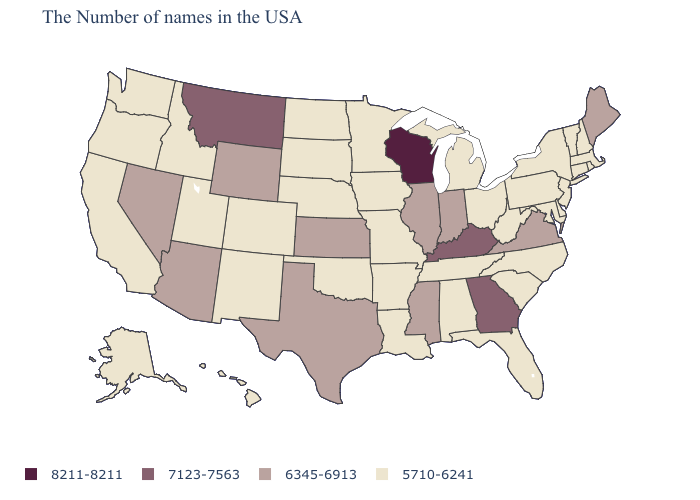Name the states that have a value in the range 6345-6913?
Be succinct. Maine, Virginia, Indiana, Illinois, Mississippi, Kansas, Texas, Wyoming, Arizona, Nevada. What is the value of Iowa?
Keep it brief. 5710-6241. What is the lowest value in states that border Rhode Island?
Give a very brief answer. 5710-6241. What is the value of Maryland?
Quick response, please. 5710-6241. Which states have the highest value in the USA?
Keep it brief. Wisconsin. What is the value of Louisiana?
Answer briefly. 5710-6241. What is the value of Kentucky?
Give a very brief answer. 7123-7563. Does Nebraska have the same value as Vermont?
Write a very short answer. Yes. Does Kentucky have a higher value than Maryland?
Quick response, please. Yes. How many symbols are there in the legend?
Keep it brief. 4. What is the value of Texas?
Concise answer only. 6345-6913. What is the value of West Virginia?
Give a very brief answer. 5710-6241. Name the states that have a value in the range 6345-6913?
Quick response, please. Maine, Virginia, Indiana, Illinois, Mississippi, Kansas, Texas, Wyoming, Arizona, Nevada. What is the value of Nebraska?
Short answer required. 5710-6241. Does Tennessee have the highest value in the South?
Be succinct. No. 